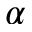Convert formula to latex. <formula><loc_0><loc_0><loc_500><loc_500>\alpha</formula> 